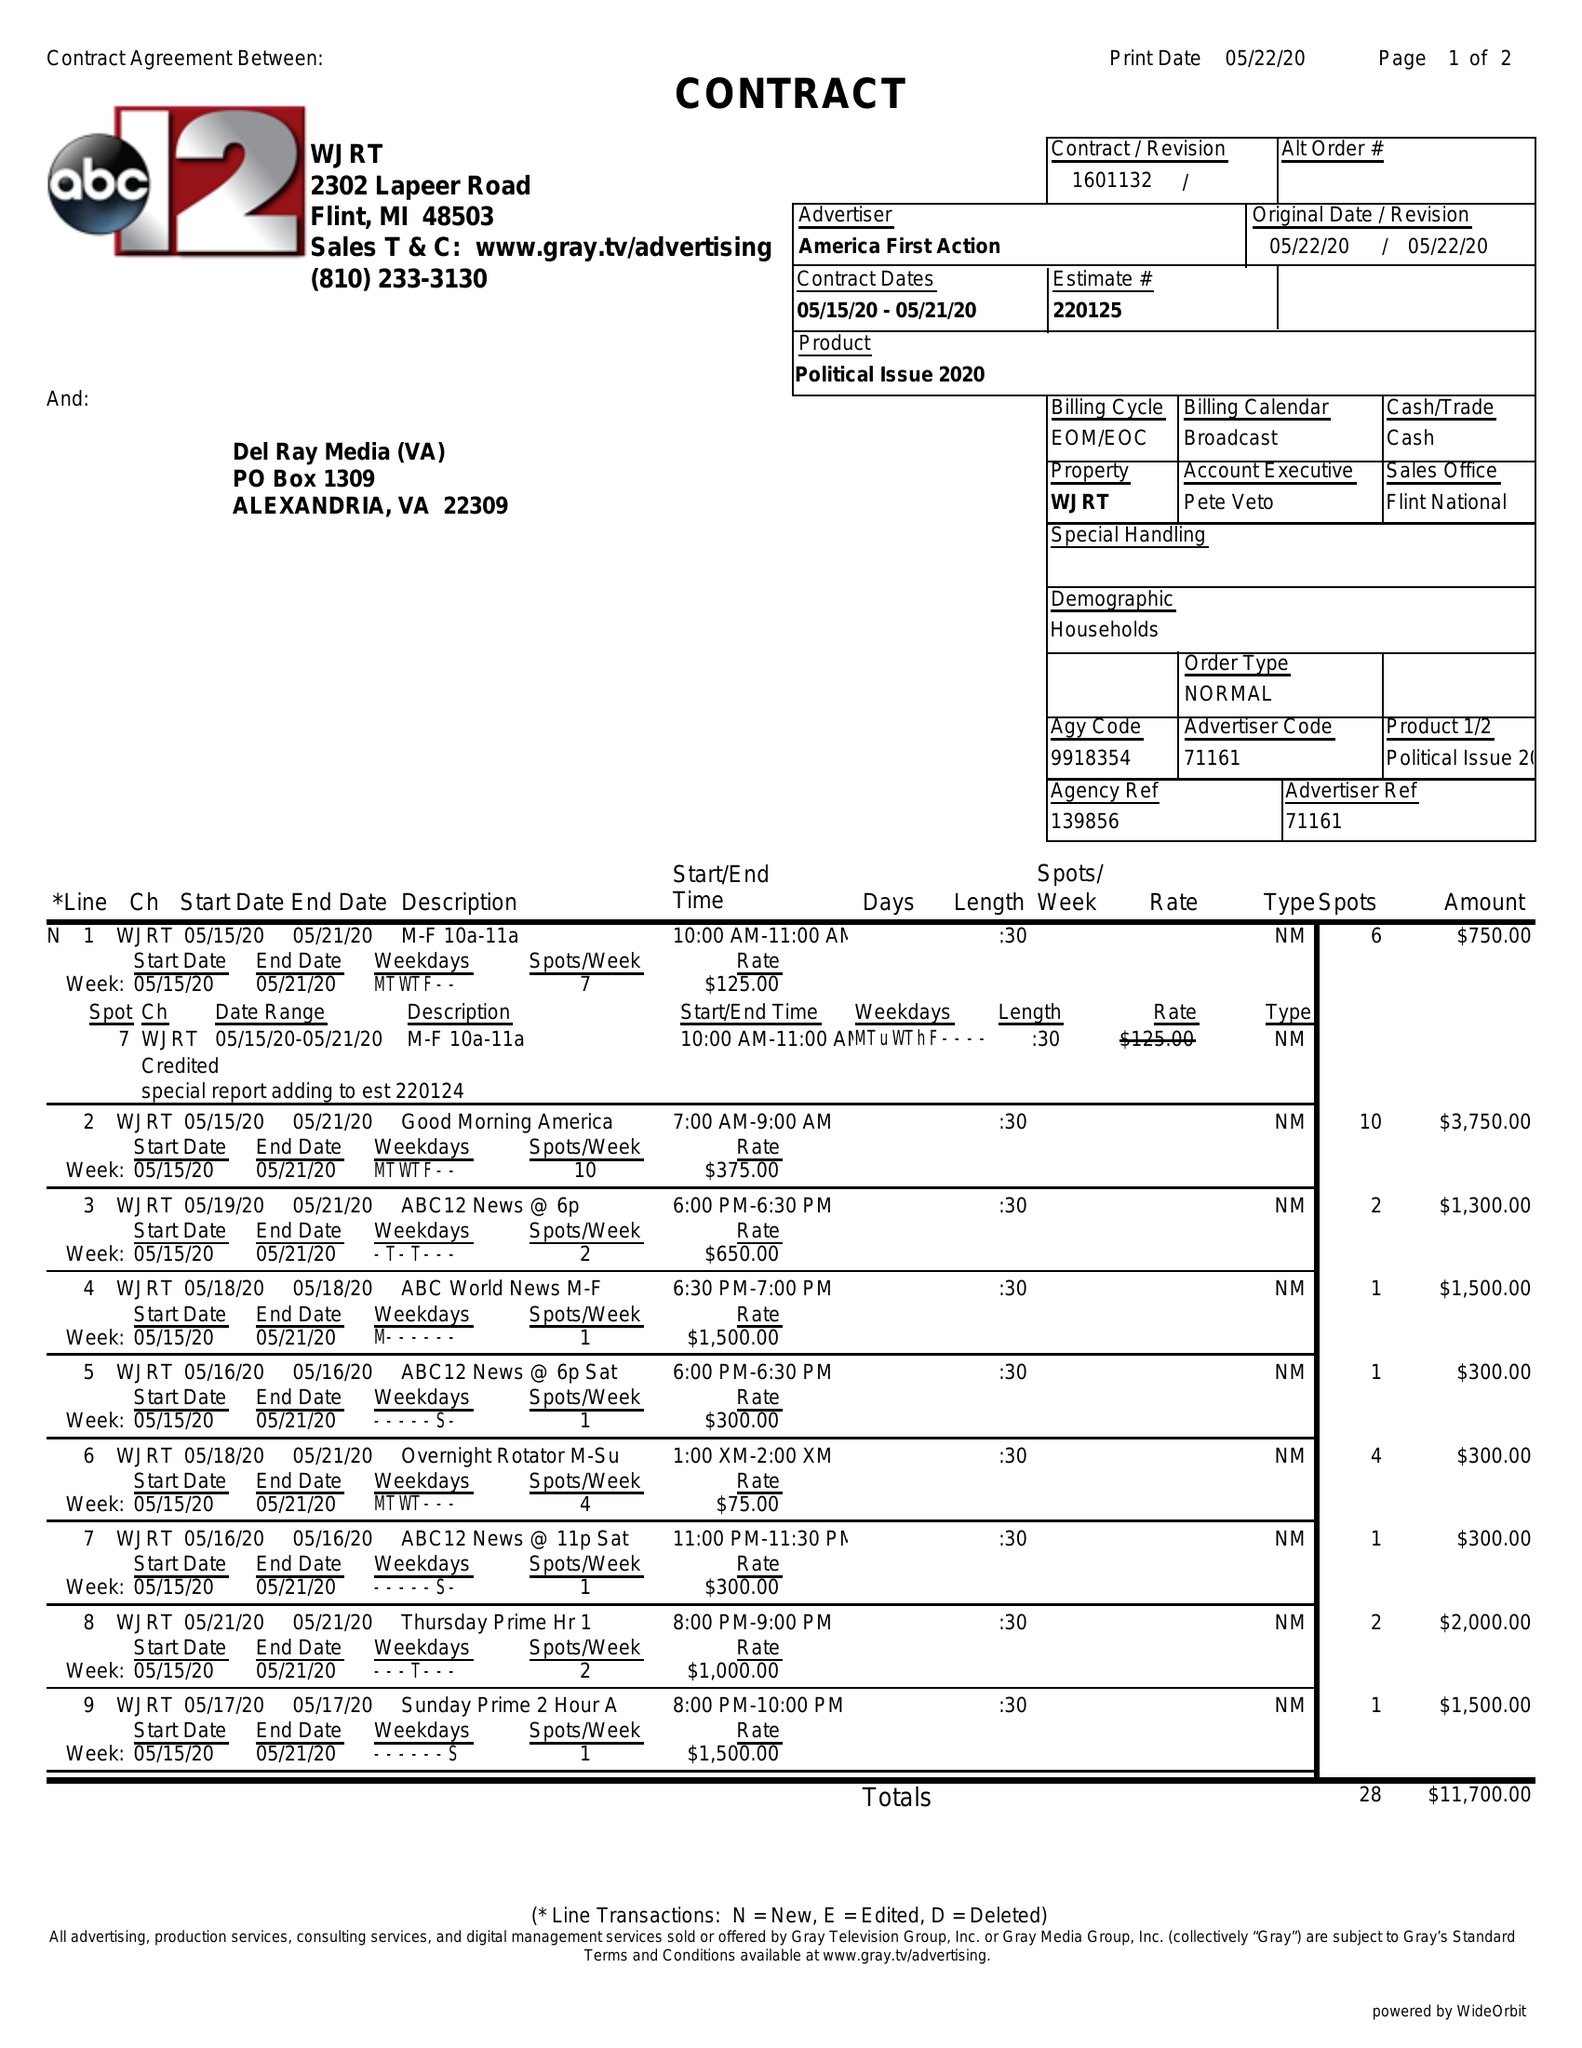What is the value for the advertiser?
Answer the question using a single word or phrase. AMERICA FIRST ACTION 